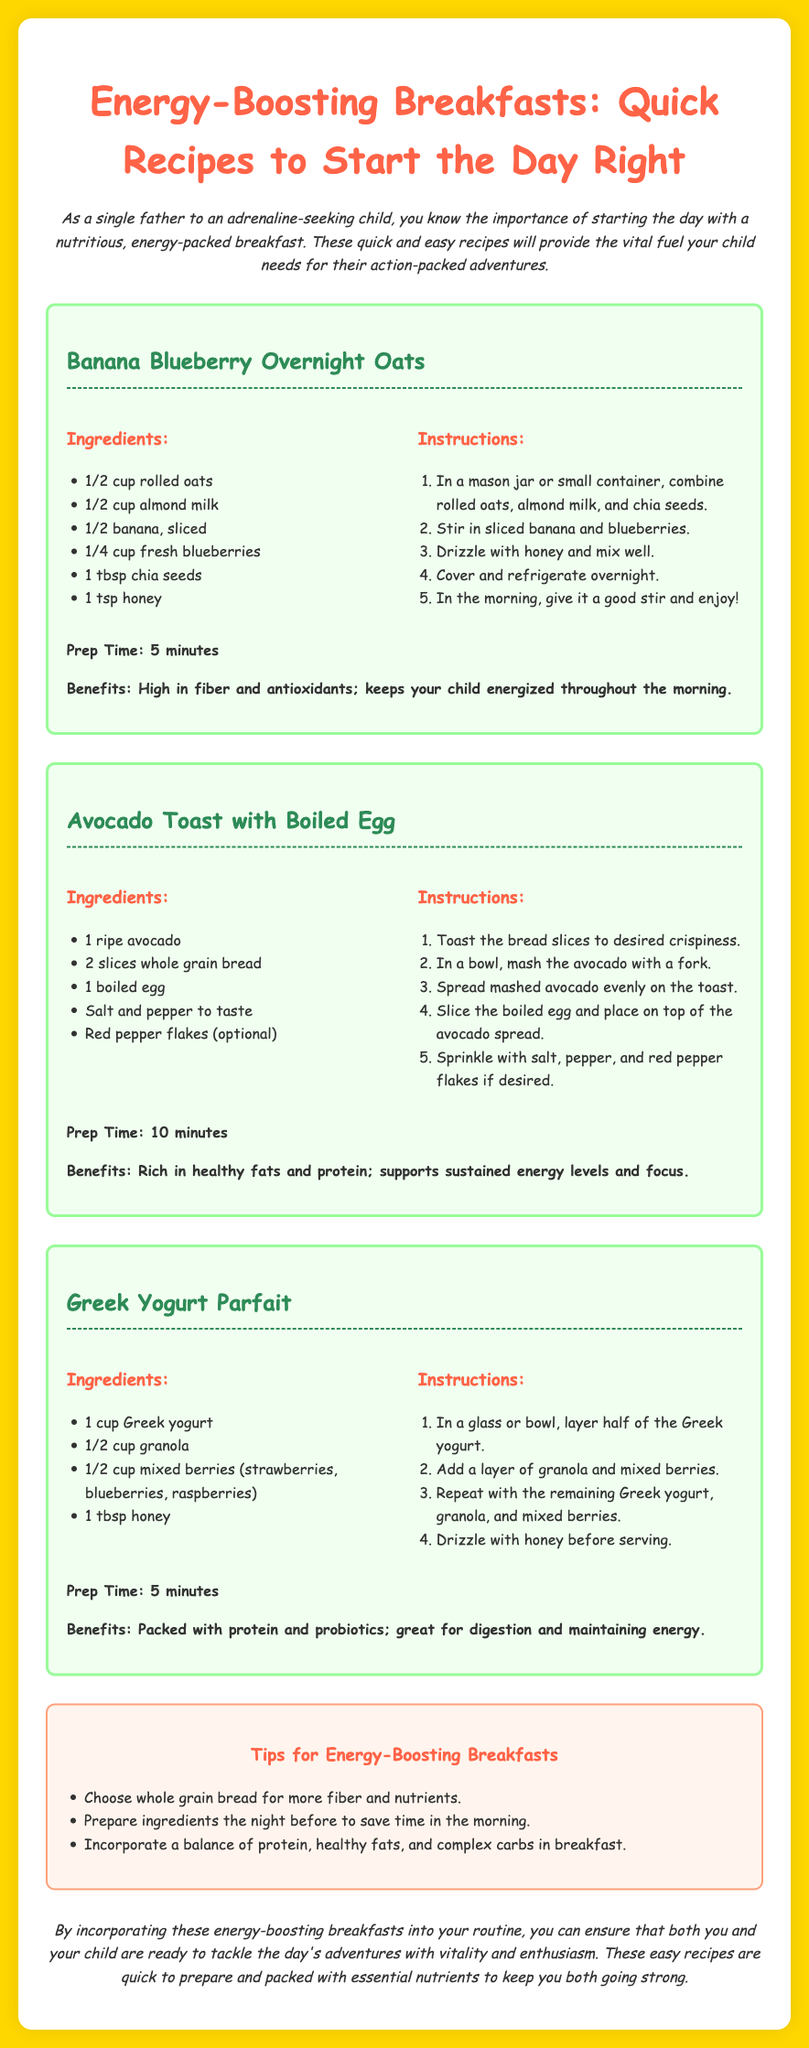what is the title of the document? The title of the document is displayed prominently at the top of the recipe card.
Answer: Energy-Boosting Breakfasts: Quick Recipes to Start the Day Right how many recipes are included in the document? There are three distinct recipes presented in the document.
Answer: three what is the prep time for the Greek Yogurt Parfait? The prep time is mentioned under the Greek Yogurt Parfait section.
Answer: 5 minutes which ingredient is used in the Avocado Toast with Boiled Egg? The ingredients are listed under the recipe for Avocado Toast with Boiled Egg.
Answer: ripe avocado what is the benefit of the Banana Blueberry Overnight Oats? Benefits are detailed under each recipe, describing the nutritional advantages.
Answer: High in fiber and antioxidants; keeps your child energized throughout the morning what common tip is provided for energy-boosting breakfasts? Tips for energy-boosting breakfasts are listed in a dedicated section.
Answer: Choose whole grain bread for more fiber and nutrients why should preparations be done the night before? This suggestion is made in the tips section to highlight efficient breakfast routines.
Answer: To save time in the morning what type of yogurt is used in the Greek Yogurt Parfait? The specific type of yogurt is stated in the list of ingredients for the parfait.
Answer: Greek yogurt 